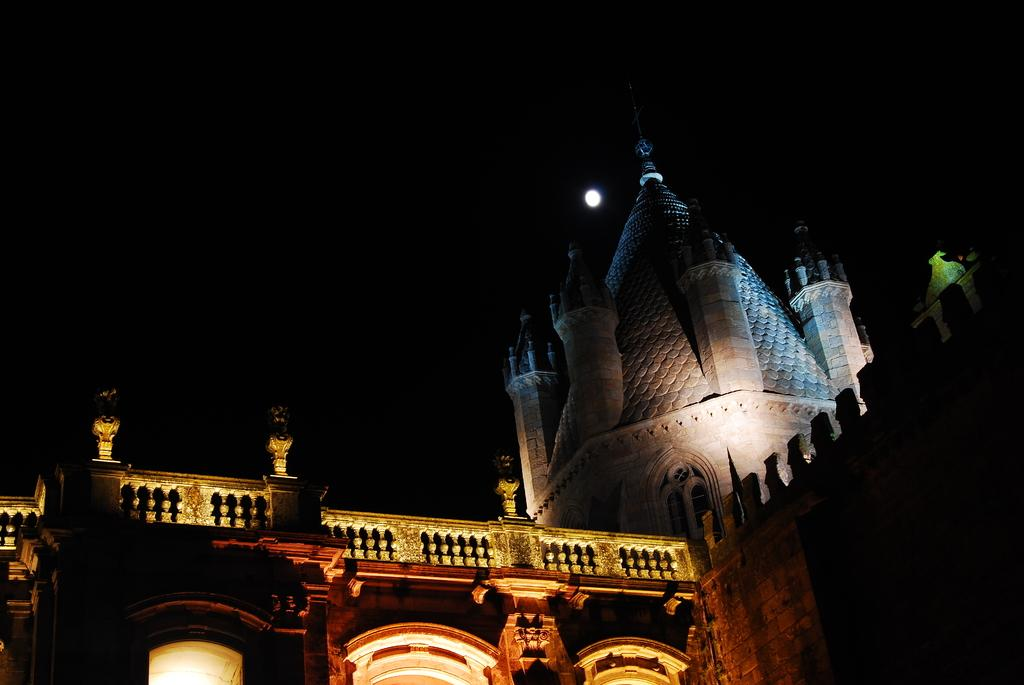What structure is visible in the image? There is a building in the image. What can be seen in the background of the image? There is a light in the background of the image. How would you describe the lighting in the image? The image is a little bit dark. How many cubs are playing with the news in the image? There are no cubs or news present in the image. What type of shoes are the feet wearing in the image? There are no feet or shoes visible in the image. 